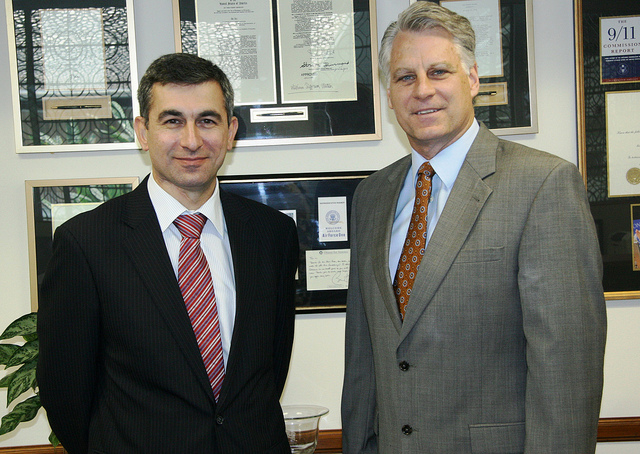Please transcribe the text in this image. 9 11 